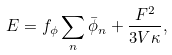Convert formula to latex. <formula><loc_0><loc_0><loc_500><loc_500>E = f _ { \phi } \sum _ { n } \bar { \phi } _ { n } + \frac { F ^ { 2 } } { 3 V \kappa } ,</formula> 